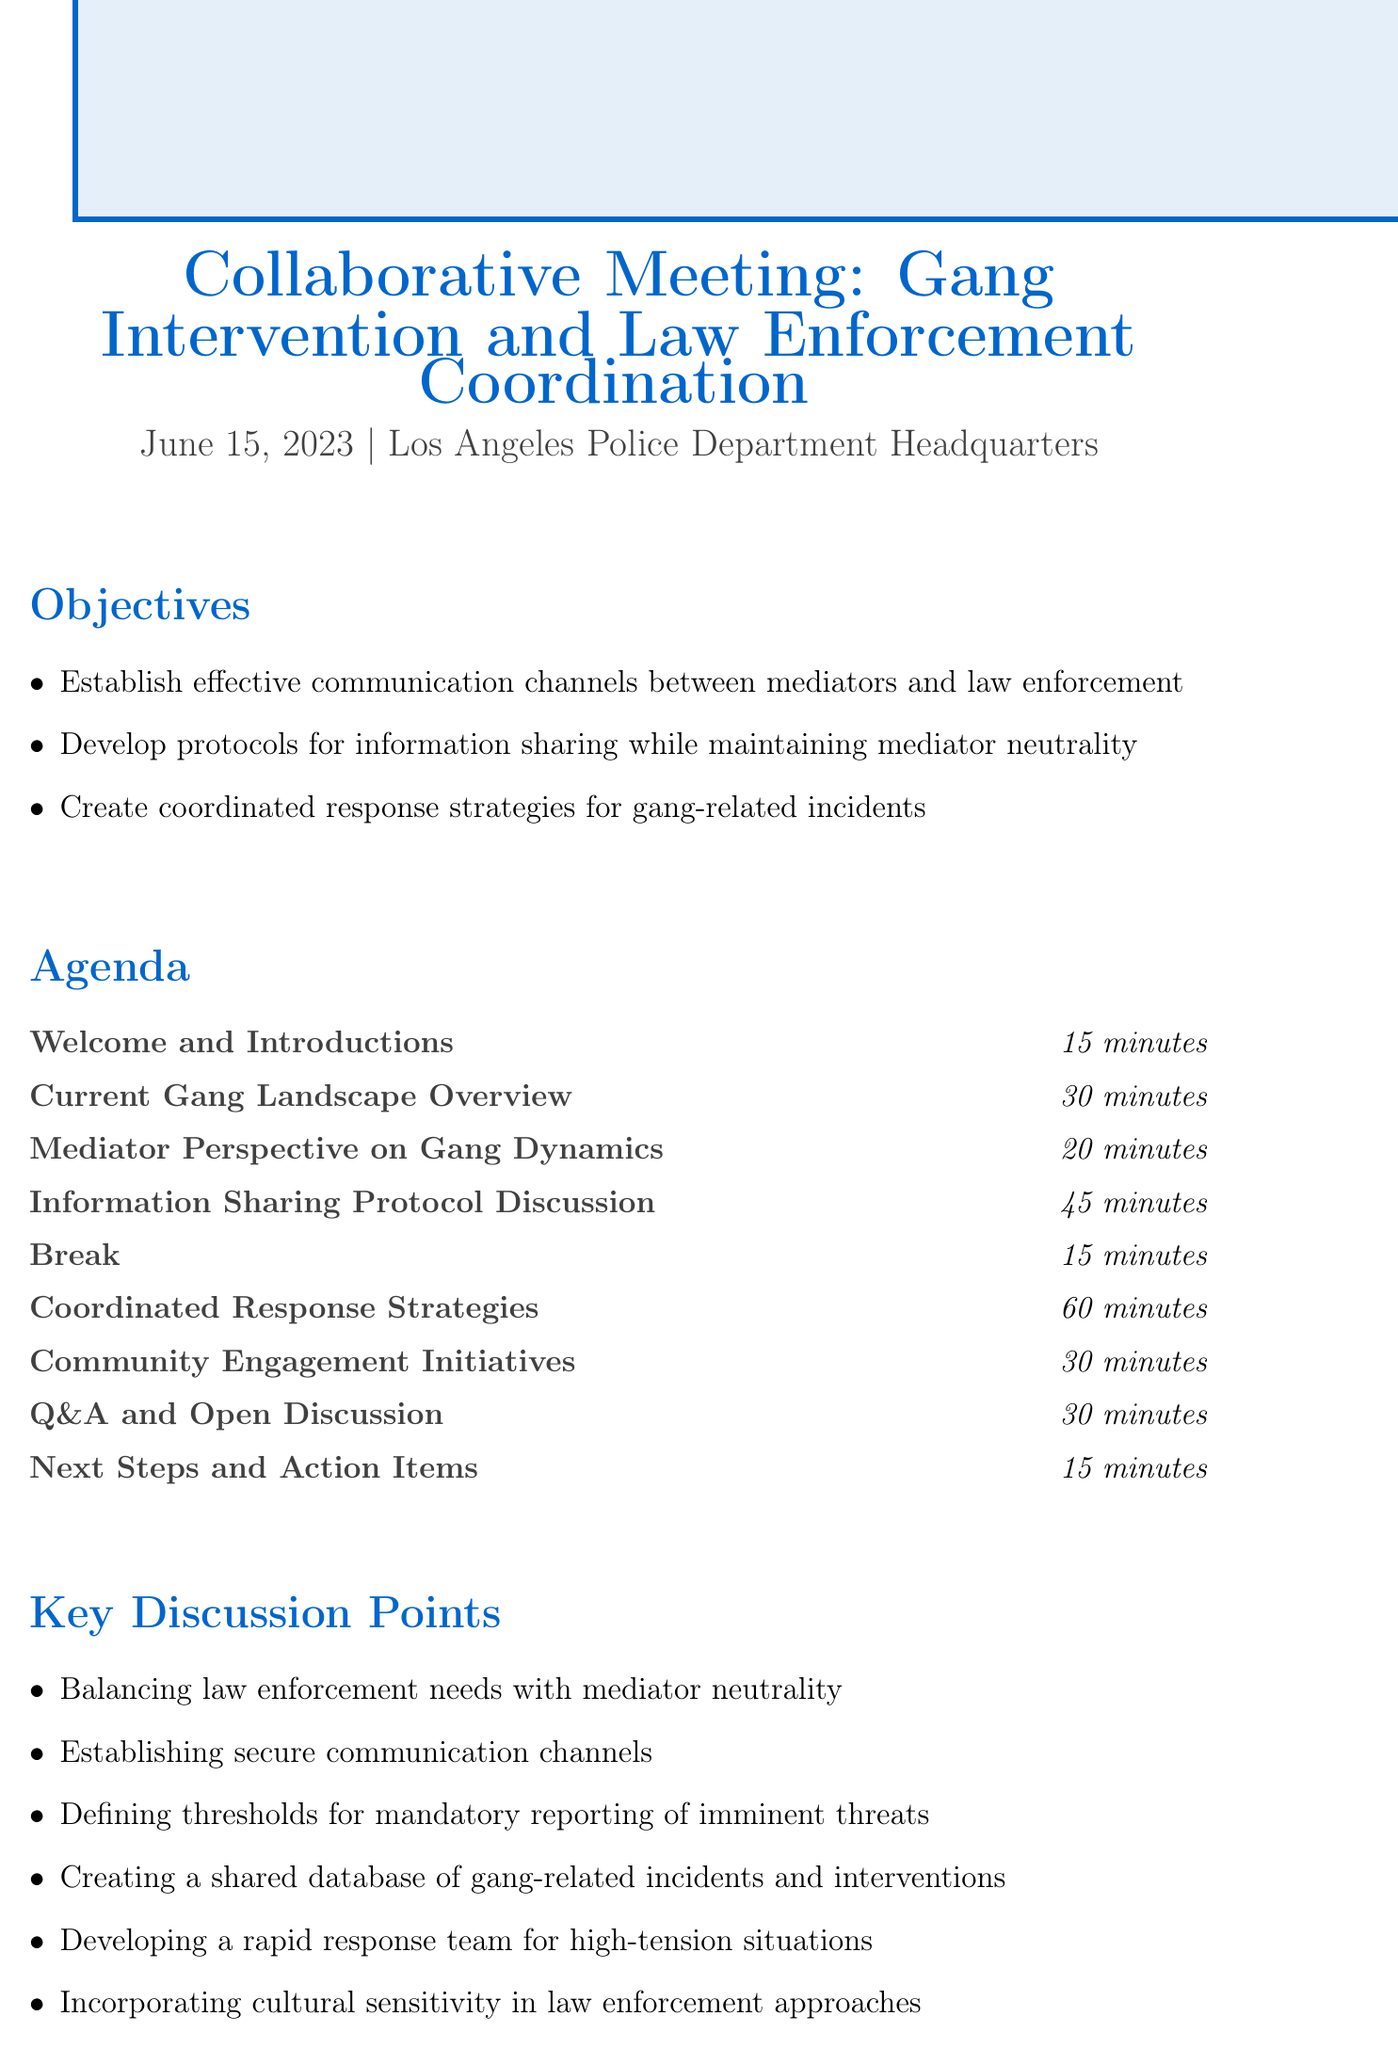What is the meeting title? The meeting title provides an overarching name for the gathering which is "Collaborative Meeting: Gang Intervention and Law Enforcement Coordination."
Answer: Collaborative Meeting: Gang Intervention and Law Enforcement Coordination When is the meeting scheduled? The date of the meeting is explicitly mentioned in the document as June 15, 2023.
Answer: June 15, 2023 How long is the "Coordinated Response Strategies" session? The duration specified for this agenda item is 60 minutes.
Answer: 60 minutes What are the main objectives of the meeting? The document lists three primary objectives aimed at enhancing collaboration between mediators and law enforcement.
Answer: Establish effective communication channels, develop protocols for information sharing while maintaining mediator neutrality, create coordinated response strategies for gang-related incidents Who will give a presentation on the current gang landscape? The document indicates that the LAPD will provide an overview of the current gang landscape.
Answer: LAPD What is one of the key discussion points mentioned? The document outlines multiple key discussion points, one of which is "Balancing law enforcement needs with mediator neutrality."
Answer: Balancing law enforcement needs with mediator neutrality What type of initiatives will be discussed regarding community engagement? The agenda item indicates that successful community programs like the Los Angeles Gang Reduction and Youth Development (GRYD) office will be presented.
Answer: Community Engagement Initiatives What resource is mentioned that relates to gang intervention best practices? The document references the "National Gang Center's Best Practices for Gang Intervention" as a related resource.
Answer: National Gang Center's Best Practices for Gang Intervention 